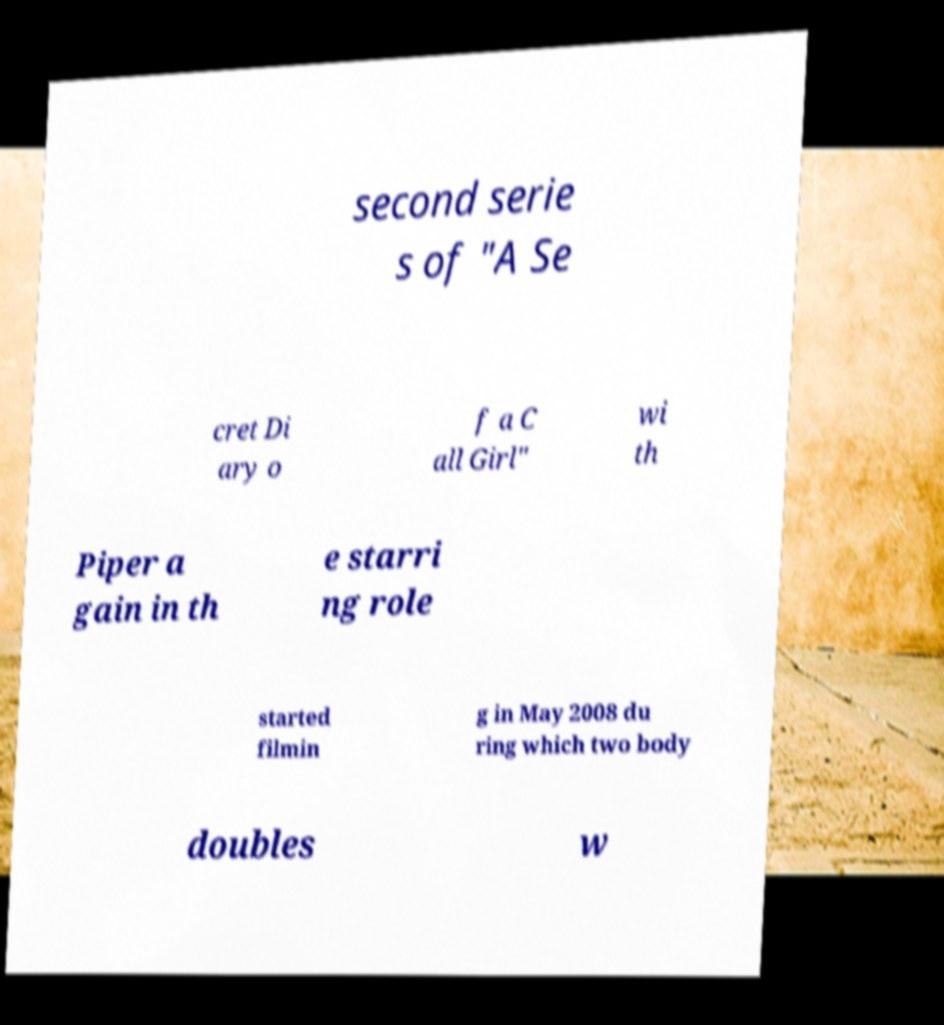There's text embedded in this image that I need extracted. Can you transcribe it verbatim? second serie s of "A Se cret Di ary o f a C all Girl" wi th Piper a gain in th e starri ng role started filmin g in May 2008 du ring which two body doubles w 